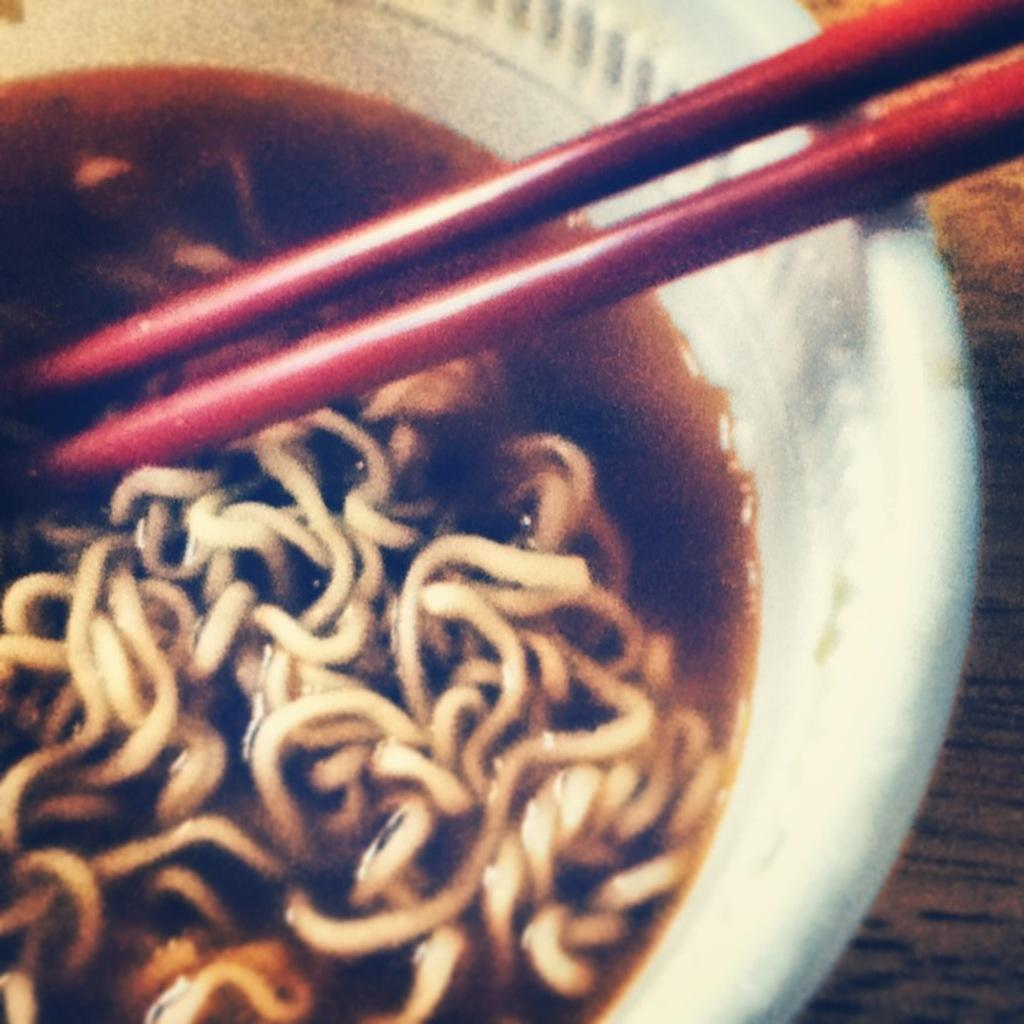What is in the bowl that is visible in the image? There are noodles in the bowl. What utensil is placed with the bowl? Chopsticks are placed with the bowl. On what is the bowl placed? The bowl is placed on a table. What type of eye can be seen in the image? There is no eye present in the image; it features a bowl of noodles with chopsticks on a table. 